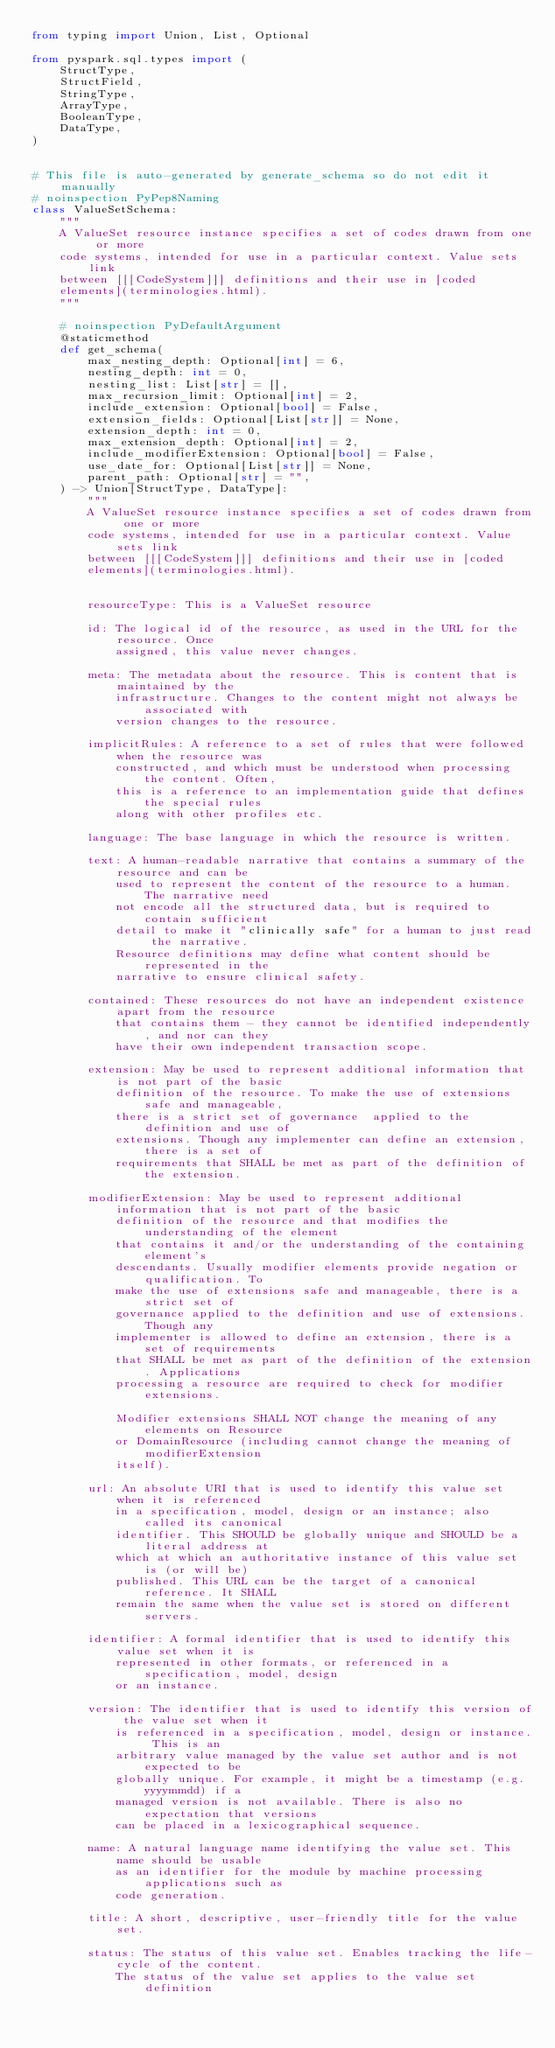<code> <loc_0><loc_0><loc_500><loc_500><_Python_>from typing import Union, List, Optional

from pyspark.sql.types import (
    StructType,
    StructField,
    StringType,
    ArrayType,
    BooleanType,
    DataType,
)


# This file is auto-generated by generate_schema so do not edit it manually
# noinspection PyPep8Naming
class ValueSetSchema:
    """
    A ValueSet resource instance specifies a set of codes drawn from one or more
    code systems, intended for use in a particular context. Value sets link
    between [[[CodeSystem]]] definitions and their use in [coded
    elements](terminologies.html).
    """

    # noinspection PyDefaultArgument
    @staticmethod
    def get_schema(
        max_nesting_depth: Optional[int] = 6,
        nesting_depth: int = 0,
        nesting_list: List[str] = [],
        max_recursion_limit: Optional[int] = 2,
        include_extension: Optional[bool] = False,
        extension_fields: Optional[List[str]] = None,
        extension_depth: int = 0,
        max_extension_depth: Optional[int] = 2,
        include_modifierExtension: Optional[bool] = False,
        use_date_for: Optional[List[str]] = None,
        parent_path: Optional[str] = "",
    ) -> Union[StructType, DataType]:
        """
        A ValueSet resource instance specifies a set of codes drawn from one or more
        code systems, intended for use in a particular context. Value sets link
        between [[[CodeSystem]]] definitions and their use in [coded
        elements](terminologies.html).


        resourceType: This is a ValueSet resource

        id: The logical id of the resource, as used in the URL for the resource. Once
            assigned, this value never changes.

        meta: The metadata about the resource. This is content that is maintained by the
            infrastructure. Changes to the content might not always be associated with
            version changes to the resource.

        implicitRules: A reference to a set of rules that were followed when the resource was
            constructed, and which must be understood when processing the content. Often,
            this is a reference to an implementation guide that defines the special rules
            along with other profiles etc.

        language: The base language in which the resource is written.

        text: A human-readable narrative that contains a summary of the resource and can be
            used to represent the content of the resource to a human. The narrative need
            not encode all the structured data, but is required to contain sufficient
            detail to make it "clinically safe" for a human to just read the narrative.
            Resource definitions may define what content should be represented in the
            narrative to ensure clinical safety.

        contained: These resources do not have an independent existence apart from the resource
            that contains them - they cannot be identified independently, and nor can they
            have their own independent transaction scope.

        extension: May be used to represent additional information that is not part of the basic
            definition of the resource. To make the use of extensions safe and manageable,
            there is a strict set of governance  applied to the definition and use of
            extensions. Though any implementer can define an extension, there is a set of
            requirements that SHALL be met as part of the definition of the extension.

        modifierExtension: May be used to represent additional information that is not part of the basic
            definition of the resource and that modifies the understanding of the element
            that contains it and/or the understanding of the containing element's
            descendants. Usually modifier elements provide negation or qualification. To
            make the use of extensions safe and manageable, there is a strict set of
            governance applied to the definition and use of extensions. Though any
            implementer is allowed to define an extension, there is a set of requirements
            that SHALL be met as part of the definition of the extension. Applications
            processing a resource are required to check for modifier extensions.

            Modifier extensions SHALL NOT change the meaning of any elements on Resource
            or DomainResource (including cannot change the meaning of modifierExtension
            itself).

        url: An absolute URI that is used to identify this value set when it is referenced
            in a specification, model, design or an instance; also called its canonical
            identifier. This SHOULD be globally unique and SHOULD be a literal address at
            which at which an authoritative instance of this value set is (or will be)
            published. This URL can be the target of a canonical reference. It SHALL
            remain the same when the value set is stored on different servers.

        identifier: A formal identifier that is used to identify this value set when it is
            represented in other formats, or referenced in a specification, model, design
            or an instance.

        version: The identifier that is used to identify this version of the value set when it
            is referenced in a specification, model, design or instance. This is an
            arbitrary value managed by the value set author and is not expected to be
            globally unique. For example, it might be a timestamp (e.g. yyyymmdd) if a
            managed version is not available. There is also no expectation that versions
            can be placed in a lexicographical sequence.

        name: A natural language name identifying the value set. This name should be usable
            as an identifier for the module by machine processing applications such as
            code generation.

        title: A short, descriptive, user-friendly title for the value set.

        status: The status of this value set. Enables tracking the life-cycle of the content.
            The status of the value set applies to the value set definition</code> 